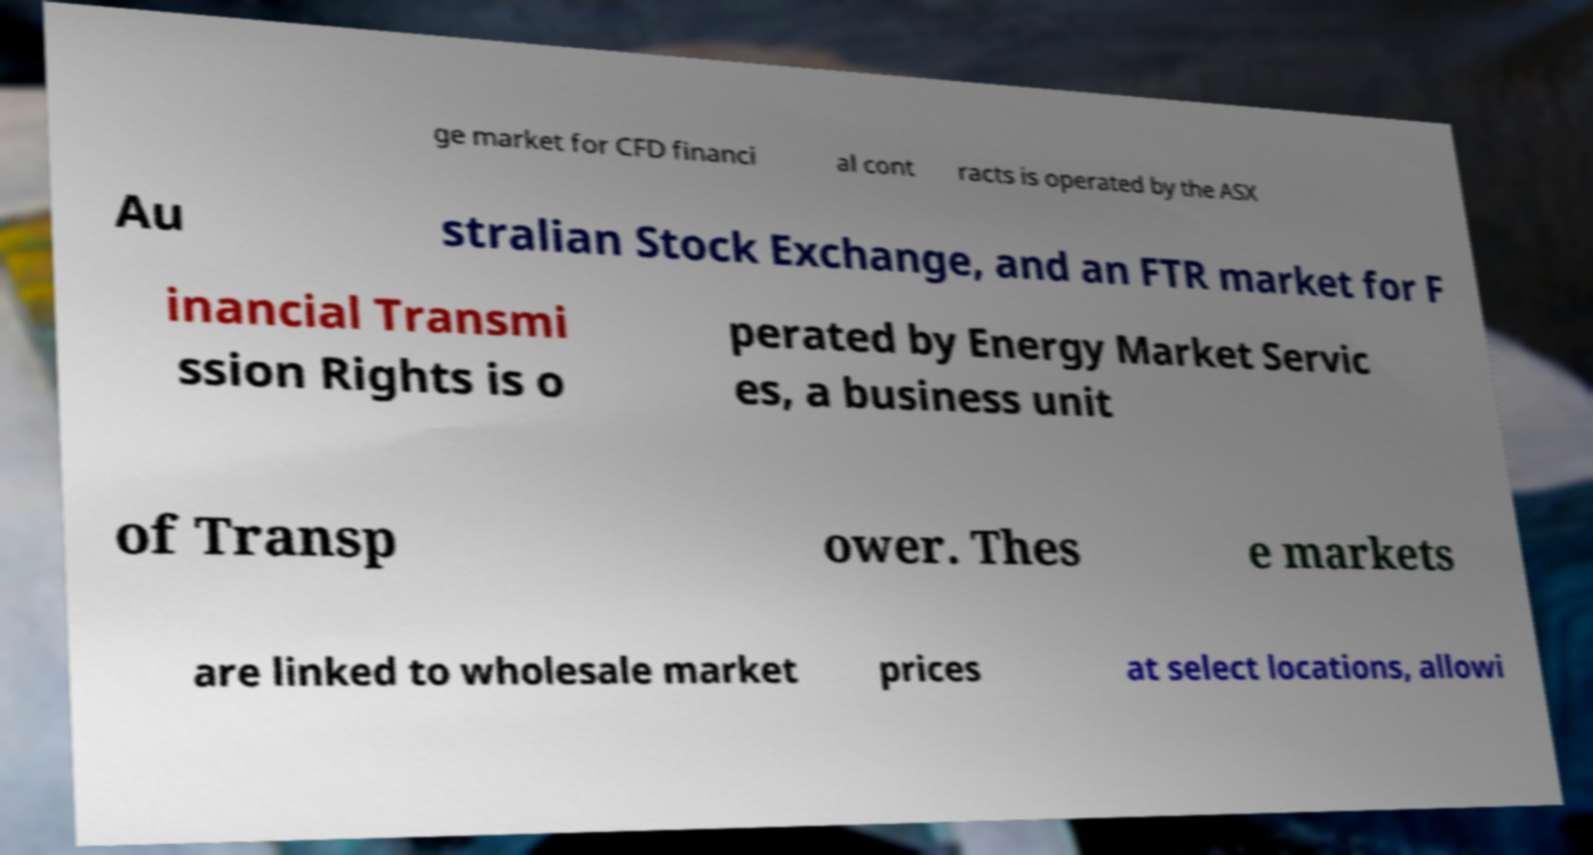Can you read and provide the text displayed in the image?This photo seems to have some interesting text. Can you extract and type it out for me? ge market for CFD financi al cont racts is operated by the ASX Au stralian Stock Exchange, and an FTR market for F inancial Transmi ssion Rights is o perated by Energy Market Servic es, a business unit of Transp ower. Thes e markets are linked to wholesale market prices at select locations, allowi 